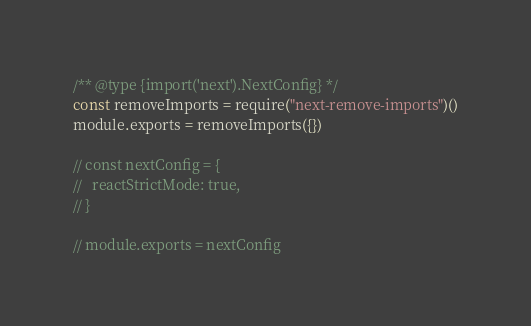<code> <loc_0><loc_0><loc_500><loc_500><_JavaScript_>/** @type {import('next').NextConfig} */
const removeImports = require("next-remove-imports")()
module.exports = removeImports({})

// const nextConfig = {
//   reactStrictMode: true,
// }

// module.exports = nextConfig
</code> 